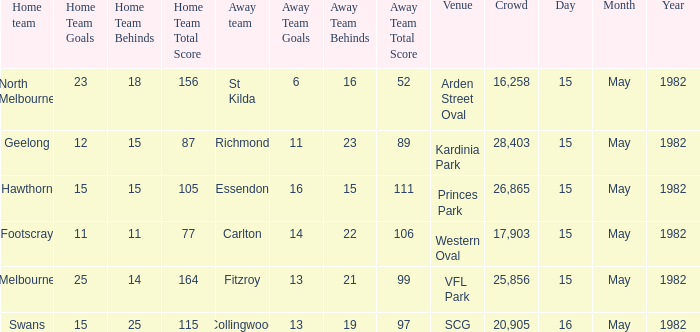Which guest team had in excess of 17,903 viewers and played against melbourne? 13.21 (99). 